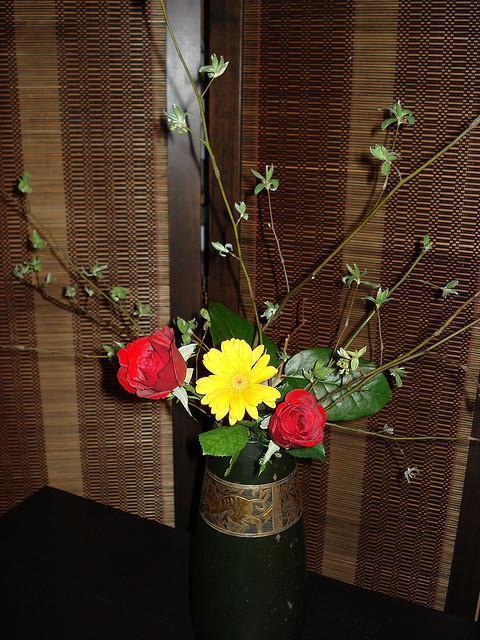How many roses are in the vase?
Give a very brief answer. 2. 